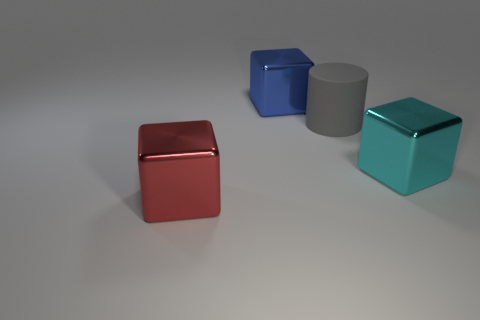Is there any other thing that is made of the same material as the cylinder?
Offer a terse response. No. What is the block that is in front of the gray thing and on the left side of the large gray cylinder made of?
Give a very brief answer. Metal. Is the number of large cubes behind the red metallic object greater than the number of red objects behind the gray thing?
Provide a succinct answer. Yes. Is there a cylinder that has the same size as the blue thing?
Your answer should be very brief. Yes. What is the color of the matte cylinder?
Make the answer very short. Gray. Are there more rubber objects in front of the blue metal thing than yellow matte cubes?
Your answer should be compact. Yes. What number of large cyan things are left of the cyan cube?
Provide a succinct answer. 0. Are there any big blue shiny blocks in front of the thing in front of the metallic cube that is to the right of the blue metallic cube?
Your answer should be very brief. No. Do the red cube and the gray cylinder have the same size?
Your answer should be very brief. Yes. Is the number of big rubber cylinders left of the big blue metal cube the same as the number of shiny blocks that are right of the large gray cylinder?
Provide a short and direct response. No. 